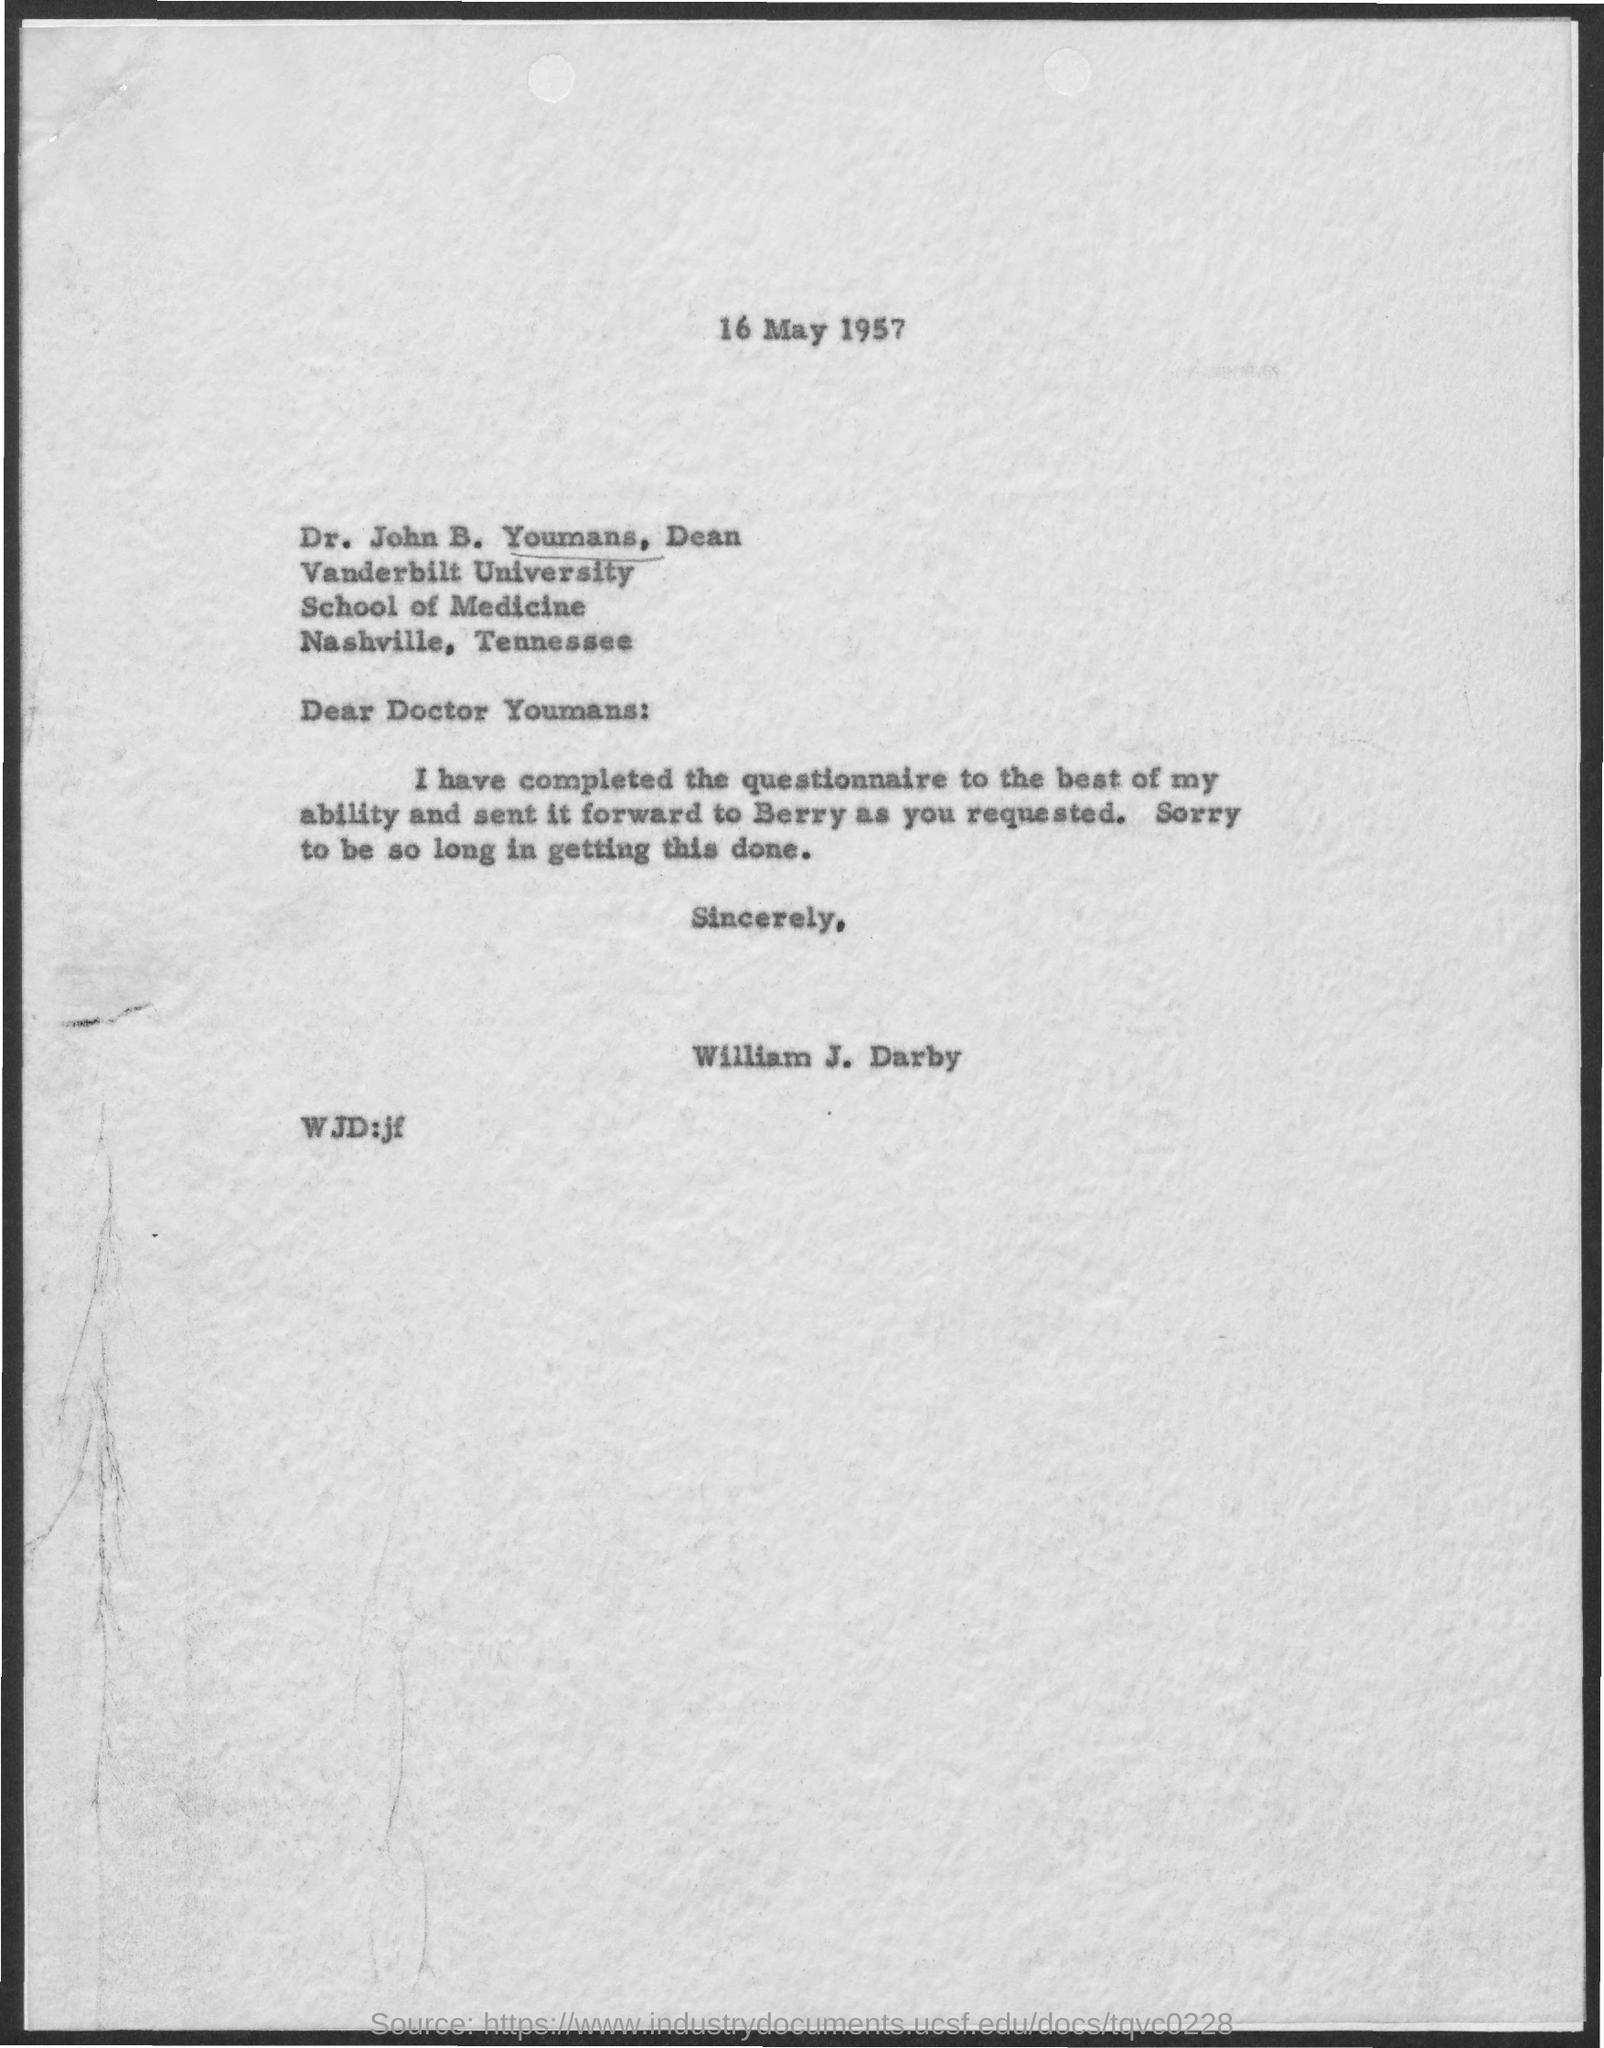What is the date on the document?
Ensure brevity in your answer.  16 May 1957. Who is this from?
Make the answer very short. William J. Darby. Who was it sent it forward to?
Your answer should be compact. Berry. 